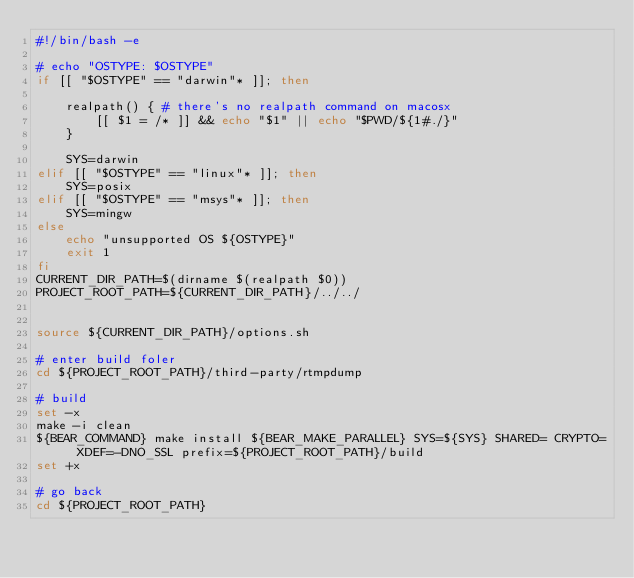Convert code to text. <code><loc_0><loc_0><loc_500><loc_500><_Bash_>#!/bin/bash -e

# echo "OSTYPE: $OSTYPE"
if [[ "$OSTYPE" == "darwin"* ]]; then

    realpath() { # there's no realpath command on macosx 
        [[ $1 = /* ]] && echo "$1" || echo "$PWD/${1#./}"
    }

    SYS=darwin
elif [[ "$OSTYPE" == "linux"* ]]; then
    SYS=posix
elif [[ "$OSTYPE" == "msys"* ]]; then
    SYS=mingw
else
    echo "unsupported OS ${OSTYPE}" 
    exit 1
fi
CURRENT_DIR_PATH=$(dirname $(realpath $0))
PROJECT_ROOT_PATH=${CURRENT_DIR_PATH}/../../


source ${CURRENT_DIR_PATH}/options.sh

# enter build foler
cd ${PROJECT_ROOT_PATH}/third-party/rtmpdump

# build
set -x
make -i clean
${BEAR_COMMAND} make install ${BEAR_MAKE_PARALLEL} SYS=${SYS} SHARED= CRYPTO= XDEF=-DNO_SSL prefix=${PROJECT_ROOT_PATH}/build
set +x

# go back
cd ${PROJECT_ROOT_PATH}

</code> 